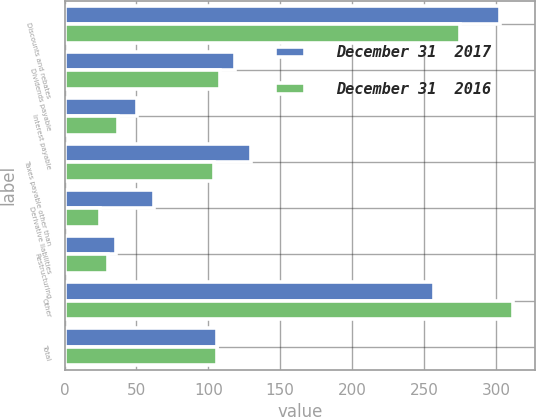Convert chart to OTSL. <chart><loc_0><loc_0><loc_500><loc_500><stacked_bar_chart><ecel><fcel>Discounts and rebates<fcel>Dividends payable<fcel>Interest payable<fcel>Taxes payable other than<fcel>Derivative liabilities<fcel>Restructuring<fcel>Other<fcel>Total<nl><fcel>December 31  2017<fcel>302.8<fcel>118.6<fcel>50.7<fcel>129.9<fcel>62.2<fcel>36<fcel>257.1<fcel>105.85<nl><fcel>December 31  2016<fcel>275.2<fcel>108<fcel>37.3<fcel>103.7<fcel>24.6<fcel>30.5<fcel>311.9<fcel>105.85<nl></chart> 